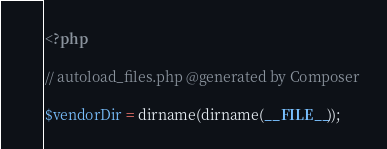Convert code to text. <code><loc_0><loc_0><loc_500><loc_500><_PHP_><?php

// autoload_files.php @generated by Composer

$vendorDir = dirname(dirname(__FILE__));</code> 